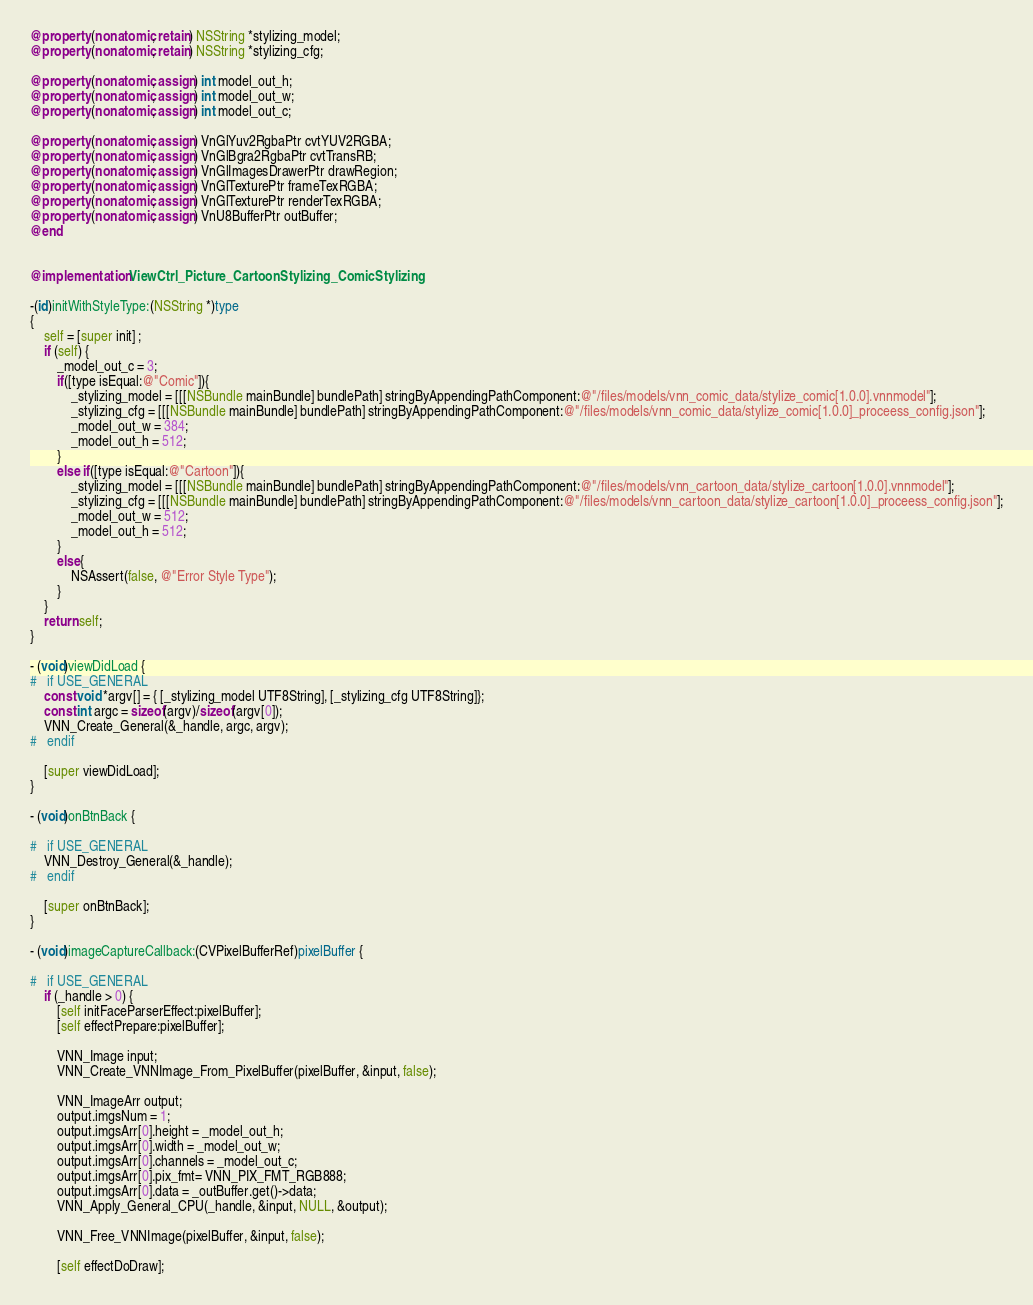<code> <loc_0><loc_0><loc_500><loc_500><_ObjectiveC_>@property (nonatomic, retain) NSString *stylizing_model;
@property (nonatomic, retain) NSString *stylizing_cfg;

@property (nonatomic, assign) int model_out_h;
@property (nonatomic, assign) int model_out_w;
@property (nonatomic, assign) int model_out_c;

@property (nonatomic, assign) VnGlYuv2RgbaPtr cvtYUV2RGBA;
@property (nonatomic, assign) VnGlBgra2RgbaPtr cvtTransRB;
@property (nonatomic, assign) VnGlImagesDrawerPtr drawRegion;
@property (nonatomic, assign) VnGlTexturePtr frameTexRGBA;
@property (nonatomic, assign) VnGlTexturePtr renderTexRGBA;
@property (nonatomic, assign) VnU8BufferPtr outBuffer;
@end


@implementation ViewCtrl_Picture_CartoonStylizing_ComicStylizing

-(id)initWithStyleType:(NSString *)type
{
    self = [super init] ;
    if (self) {
        _model_out_c = 3;
        if([type isEqual:@"Comic"]){
            _stylizing_model = [[[NSBundle mainBundle] bundlePath] stringByAppendingPathComponent:@"/files/models/vnn_comic_data/stylize_comic[1.0.0].vnnmodel"];
            _stylizing_cfg = [[[NSBundle mainBundle] bundlePath] stringByAppendingPathComponent:@"/files/models/vnn_comic_data/stylize_comic[1.0.0]_proceess_config.json"];
            _model_out_w = 384;
            _model_out_h = 512;
        }
        else if([type isEqual:@"Cartoon"]){
            _stylizing_model = [[[NSBundle mainBundle] bundlePath] stringByAppendingPathComponent:@"/files/models/vnn_cartoon_data/stylize_cartoon[1.0.0].vnnmodel"];
            _stylizing_cfg = [[[NSBundle mainBundle] bundlePath] stringByAppendingPathComponent:@"/files/models/vnn_cartoon_data/stylize_cartoon[1.0.0]_proceess_config.json"];
            _model_out_w = 512;
            _model_out_h = 512;
        }
        else{
            NSAssert(false, @"Error Style Type");
        }
    }
    return self;
}

- (void)viewDidLoad {
#   if USE_GENERAL
    const void *argv[] = { [_stylizing_model UTF8String], [_stylizing_cfg UTF8String]};
    const int argc = sizeof(argv)/sizeof(argv[0]);
    VNN_Create_General(&_handle, argc, argv);
#   endif
    
    [super viewDidLoad];
}

- (void)onBtnBack {
    
#   if USE_GENERAL
    VNN_Destroy_General(&_handle);
#   endif
    
    [super onBtnBack];
}

- (void)imageCaptureCallback:(CVPixelBufferRef)pixelBuffer {
    
#   if USE_GENERAL
    if (_handle > 0) {
        [self initFaceParserEffect:pixelBuffer];
        [self effectPrepare:pixelBuffer];
        
        VNN_Image input;
        VNN_Create_VNNImage_From_PixelBuffer(pixelBuffer, &input, false);
        
        VNN_ImageArr output;
        output.imgsNum = 1;
        output.imgsArr[0].height = _model_out_h;
        output.imgsArr[0].width = _model_out_w;
        output.imgsArr[0].channels = _model_out_c;
        output.imgsArr[0].pix_fmt= VNN_PIX_FMT_RGB888;
        output.imgsArr[0].data = _outBuffer.get()->data;
        VNN_Apply_General_CPU(_handle, &input, NULL, &output);
        
        VNN_Free_VNNImage(pixelBuffer, &input, false);
        
        [self effectDoDraw];</code> 